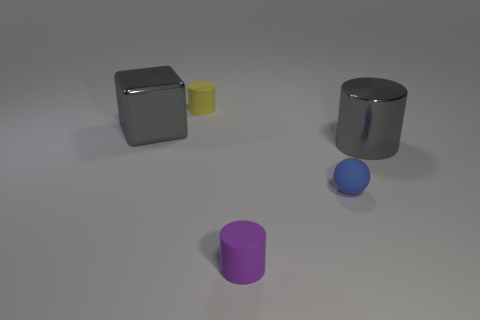Do the yellow thing to the left of the gray cylinder and the purple thing that is in front of the large metal cylinder have the same shape?
Provide a succinct answer. Yes. Is there any other thing that has the same color as the metal block?
Your answer should be compact. Yes. The small yellow object that is made of the same material as the purple cylinder is what shape?
Give a very brief answer. Cylinder. There is a object that is both in front of the yellow cylinder and behind the big metal cylinder; what material is it made of?
Your response must be concise. Metal. Do the big shiny block and the large cylinder have the same color?
Give a very brief answer. Yes. The shiny object that is the same color as the shiny cylinder is what shape?
Offer a terse response. Cube. How many other tiny objects have the same shape as the blue thing?
Provide a short and direct response. 0. There is a gray cylinder that is the same material as the block; what size is it?
Ensure brevity in your answer.  Large. Is the size of the purple rubber cylinder the same as the blue rubber object?
Your answer should be very brief. Yes. Is there a tiny blue metal object?
Make the answer very short. No. 